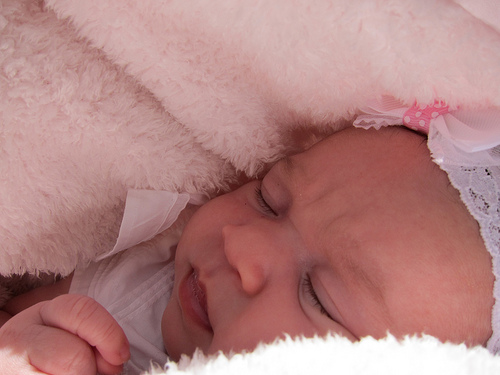<image>
Is the baby under the blanket? Yes. The baby is positioned underneath the blanket, with the blanket above it in the vertical space. 